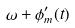Convert formula to latex. <formula><loc_0><loc_0><loc_500><loc_500>\omega + \phi _ { m } ^ { \prime } ( t )</formula> 